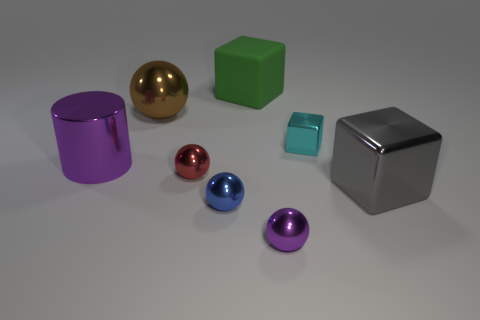What material is the big block to the left of the small purple sphere?
Your answer should be very brief. Rubber. The green matte object is what size?
Your answer should be compact. Large. How many yellow objects are tiny metal blocks or rubber cylinders?
Make the answer very short. 0. There is a cyan object that is on the right side of the big block behind the large ball; what size is it?
Your response must be concise. Small. There is a large matte block; is its color the same as the large metal thing that is behind the large purple cylinder?
Your response must be concise. No. How many other objects are the same material as the tiny cyan block?
Keep it short and to the point. 6. There is a big brown thing that is made of the same material as the large gray block; what is its shape?
Offer a terse response. Sphere. Is there any other thing that has the same color as the tiny metal block?
Your response must be concise. No. There is a sphere that is the same color as the cylinder; what size is it?
Offer a very short reply. Small. Is the number of purple metal things that are right of the cyan object greater than the number of cyan objects?
Make the answer very short. No. 